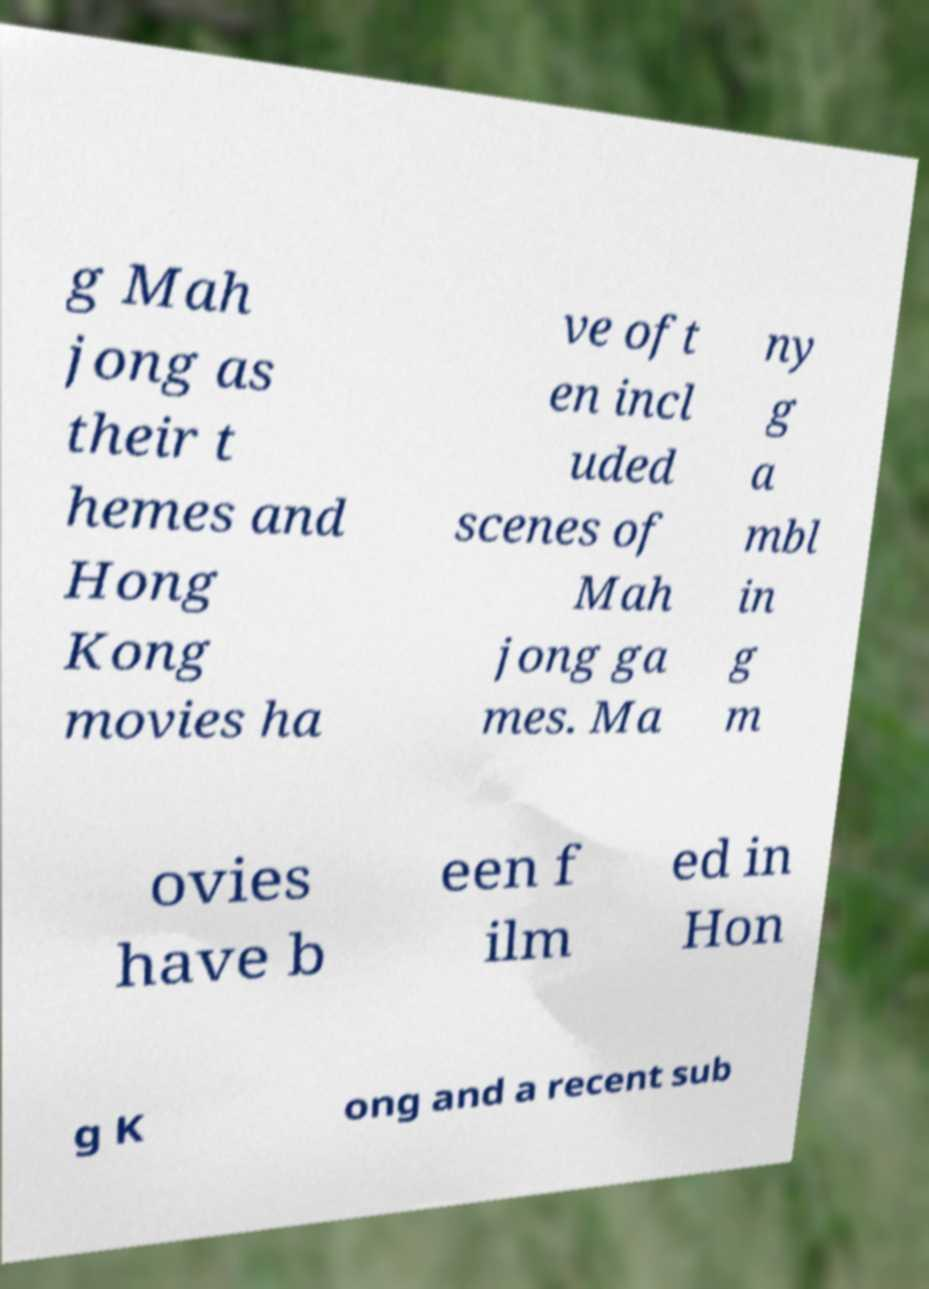For documentation purposes, I need the text within this image transcribed. Could you provide that? g Mah jong as their t hemes and Hong Kong movies ha ve oft en incl uded scenes of Mah jong ga mes. Ma ny g a mbl in g m ovies have b een f ilm ed in Hon g K ong and a recent sub 